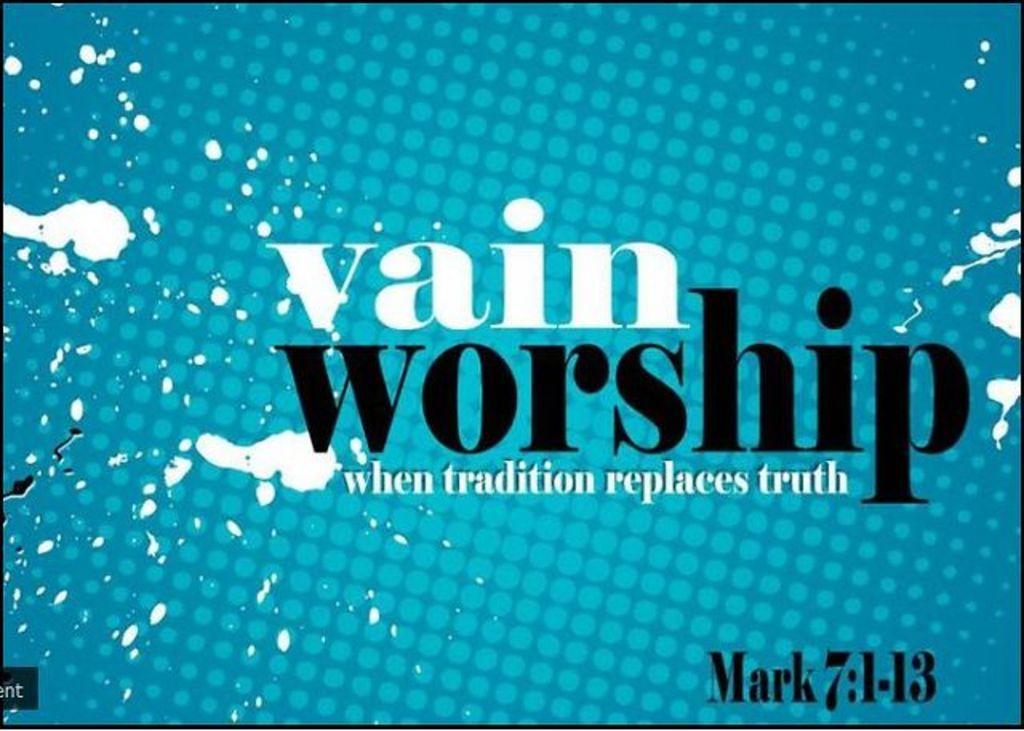Are you familiar with that bible verse?
Make the answer very short. No. 